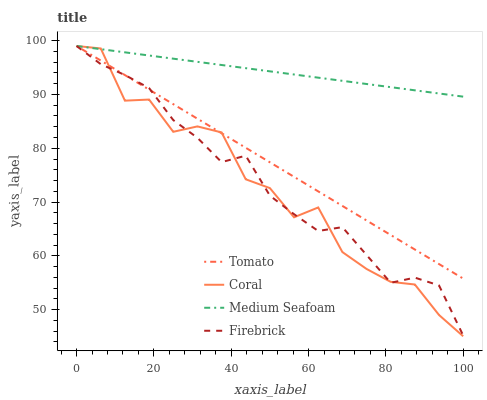Does Coral have the minimum area under the curve?
Answer yes or no. Yes. Does Medium Seafoam have the maximum area under the curve?
Answer yes or no. Yes. Does Firebrick have the minimum area under the curve?
Answer yes or no. No. Does Firebrick have the maximum area under the curve?
Answer yes or no. No. Is Medium Seafoam the smoothest?
Answer yes or no. Yes. Is Coral the roughest?
Answer yes or no. Yes. Is Firebrick the smoothest?
Answer yes or no. No. Is Firebrick the roughest?
Answer yes or no. No. Does Firebrick have the lowest value?
Answer yes or no. No. Does Medium Seafoam have the highest value?
Answer yes or no. Yes. Does Tomato intersect Medium Seafoam?
Answer yes or no. Yes. Is Tomato less than Medium Seafoam?
Answer yes or no. No. Is Tomato greater than Medium Seafoam?
Answer yes or no. No. 